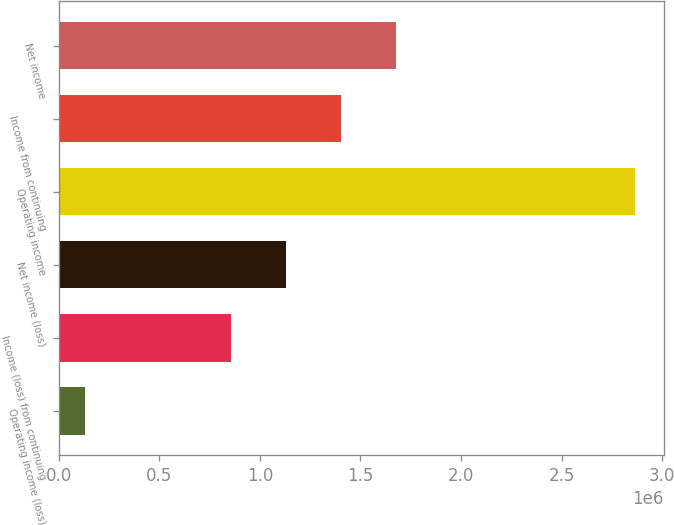Convert chart to OTSL. <chart><loc_0><loc_0><loc_500><loc_500><bar_chart><fcel>Operating income (loss)<fcel>Income (loss) from continuing<fcel>Net income (loss)<fcel>Operating income<fcel>Income from continuing<fcel>Net income<nl><fcel>129603<fcel>855286<fcel>1.12872e+06<fcel>2.86393e+06<fcel>1.40215e+06<fcel>1.67558e+06<nl></chart> 